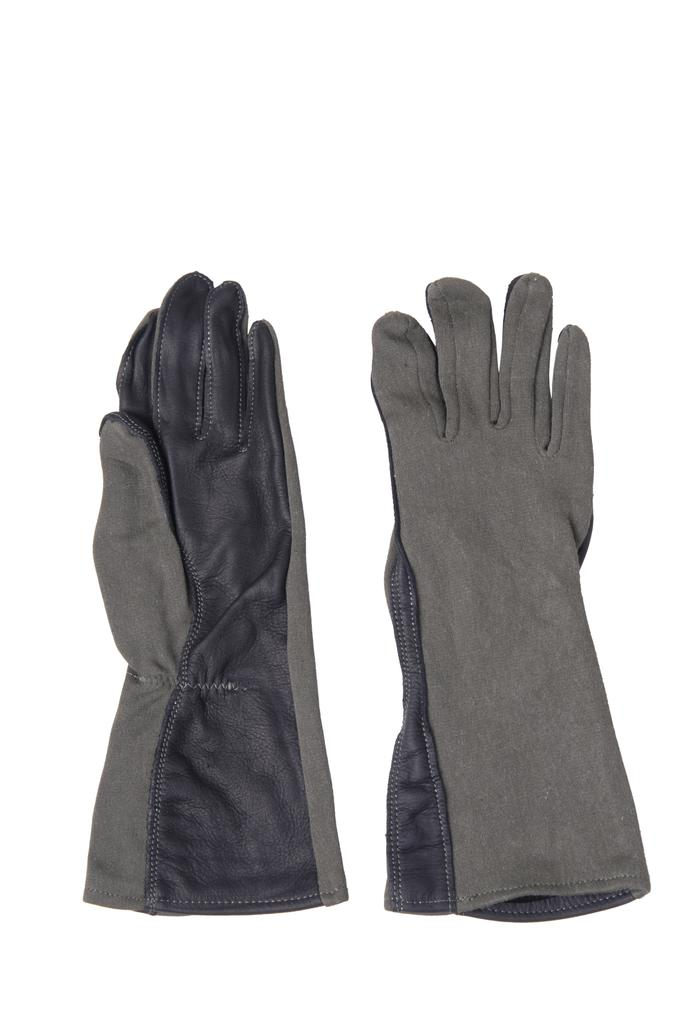What type of clothing item is present in the image? There are hand gloves in the image. What color is the background of the image? The background of the image is white. What type of ant can be seen crawling on the father's sink in the image? There is no father, ant, or sink present in the image; it only features hand gloves. 